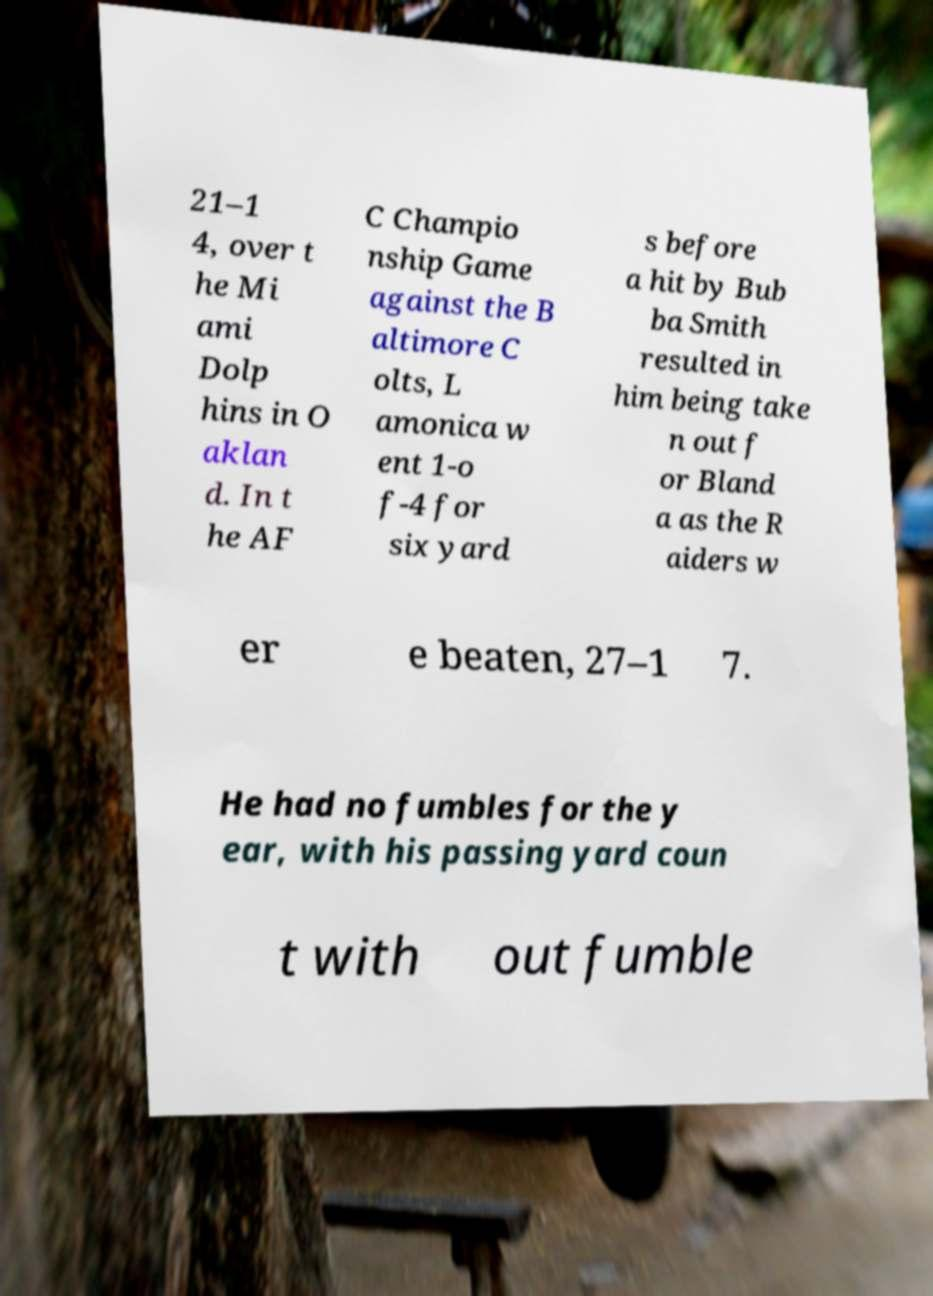Please read and relay the text visible in this image. What does it say? 21–1 4, over t he Mi ami Dolp hins in O aklan d. In t he AF C Champio nship Game against the B altimore C olts, L amonica w ent 1-o f-4 for six yard s before a hit by Bub ba Smith resulted in him being take n out f or Bland a as the R aiders w er e beaten, 27–1 7. He had no fumbles for the y ear, with his passing yard coun t with out fumble 